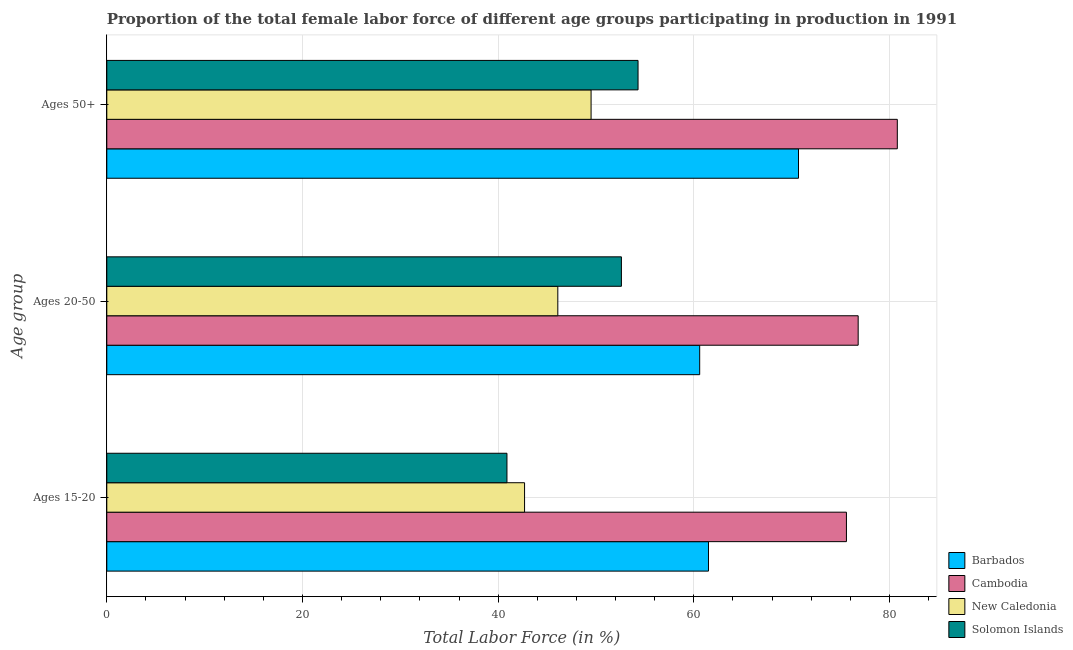How many different coloured bars are there?
Make the answer very short. 4. Are the number of bars per tick equal to the number of legend labels?
Offer a terse response. Yes. Are the number of bars on each tick of the Y-axis equal?
Give a very brief answer. Yes. What is the label of the 3rd group of bars from the top?
Offer a terse response. Ages 15-20. What is the percentage of female labor force within the age group 20-50 in Solomon Islands?
Ensure brevity in your answer.  52.6. Across all countries, what is the maximum percentage of female labor force within the age group 20-50?
Ensure brevity in your answer.  76.8. Across all countries, what is the minimum percentage of female labor force within the age group 20-50?
Offer a very short reply. 46.1. In which country was the percentage of female labor force above age 50 maximum?
Give a very brief answer. Cambodia. In which country was the percentage of female labor force above age 50 minimum?
Keep it short and to the point. New Caledonia. What is the total percentage of female labor force within the age group 20-50 in the graph?
Provide a succinct answer. 236.1. What is the difference between the percentage of female labor force within the age group 20-50 in Cambodia and that in New Caledonia?
Make the answer very short. 30.7. What is the difference between the percentage of female labor force within the age group 20-50 in New Caledonia and the percentage of female labor force above age 50 in Cambodia?
Ensure brevity in your answer.  -34.7. What is the average percentage of female labor force above age 50 per country?
Offer a very short reply. 63.82. What is the difference between the percentage of female labor force within the age group 20-50 and percentage of female labor force above age 50 in New Caledonia?
Give a very brief answer. -3.4. What is the ratio of the percentage of female labor force within the age group 20-50 in New Caledonia to that in Barbados?
Offer a very short reply. 0.76. What is the difference between the highest and the second highest percentage of female labor force within the age group 15-20?
Make the answer very short. 14.1. What is the difference between the highest and the lowest percentage of female labor force within the age group 15-20?
Your answer should be compact. 34.7. In how many countries, is the percentage of female labor force above age 50 greater than the average percentage of female labor force above age 50 taken over all countries?
Make the answer very short. 2. Is the sum of the percentage of female labor force within the age group 20-50 in New Caledonia and Barbados greater than the maximum percentage of female labor force above age 50 across all countries?
Your response must be concise. Yes. What does the 4th bar from the top in Ages 15-20 represents?
Your answer should be compact. Barbados. What does the 2nd bar from the bottom in Ages 20-50 represents?
Your answer should be very brief. Cambodia. Is it the case that in every country, the sum of the percentage of female labor force within the age group 15-20 and percentage of female labor force within the age group 20-50 is greater than the percentage of female labor force above age 50?
Your answer should be compact. Yes. What is the difference between two consecutive major ticks on the X-axis?
Your answer should be very brief. 20. Does the graph contain any zero values?
Provide a short and direct response. No. Does the graph contain grids?
Your answer should be very brief. Yes. What is the title of the graph?
Make the answer very short. Proportion of the total female labor force of different age groups participating in production in 1991. What is the label or title of the X-axis?
Your response must be concise. Total Labor Force (in %). What is the label or title of the Y-axis?
Make the answer very short. Age group. What is the Total Labor Force (in %) in Barbados in Ages 15-20?
Offer a terse response. 61.5. What is the Total Labor Force (in %) in Cambodia in Ages 15-20?
Provide a succinct answer. 75.6. What is the Total Labor Force (in %) of New Caledonia in Ages 15-20?
Your answer should be compact. 42.7. What is the Total Labor Force (in %) of Solomon Islands in Ages 15-20?
Make the answer very short. 40.9. What is the Total Labor Force (in %) of Barbados in Ages 20-50?
Your response must be concise. 60.6. What is the Total Labor Force (in %) of Cambodia in Ages 20-50?
Provide a succinct answer. 76.8. What is the Total Labor Force (in %) in New Caledonia in Ages 20-50?
Your answer should be very brief. 46.1. What is the Total Labor Force (in %) of Solomon Islands in Ages 20-50?
Your response must be concise. 52.6. What is the Total Labor Force (in %) in Barbados in Ages 50+?
Your answer should be compact. 70.7. What is the Total Labor Force (in %) of Cambodia in Ages 50+?
Give a very brief answer. 80.8. What is the Total Labor Force (in %) of New Caledonia in Ages 50+?
Your answer should be very brief. 49.5. What is the Total Labor Force (in %) of Solomon Islands in Ages 50+?
Your response must be concise. 54.3. Across all Age group, what is the maximum Total Labor Force (in %) in Barbados?
Make the answer very short. 70.7. Across all Age group, what is the maximum Total Labor Force (in %) of Cambodia?
Ensure brevity in your answer.  80.8. Across all Age group, what is the maximum Total Labor Force (in %) of New Caledonia?
Your answer should be compact. 49.5. Across all Age group, what is the maximum Total Labor Force (in %) of Solomon Islands?
Provide a short and direct response. 54.3. Across all Age group, what is the minimum Total Labor Force (in %) in Barbados?
Offer a terse response. 60.6. Across all Age group, what is the minimum Total Labor Force (in %) in Cambodia?
Ensure brevity in your answer.  75.6. Across all Age group, what is the minimum Total Labor Force (in %) in New Caledonia?
Give a very brief answer. 42.7. Across all Age group, what is the minimum Total Labor Force (in %) of Solomon Islands?
Ensure brevity in your answer.  40.9. What is the total Total Labor Force (in %) of Barbados in the graph?
Your response must be concise. 192.8. What is the total Total Labor Force (in %) in Cambodia in the graph?
Provide a succinct answer. 233.2. What is the total Total Labor Force (in %) of New Caledonia in the graph?
Your answer should be very brief. 138.3. What is the total Total Labor Force (in %) of Solomon Islands in the graph?
Give a very brief answer. 147.8. What is the difference between the Total Labor Force (in %) of New Caledonia in Ages 15-20 and that in Ages 20-50?
Provide a short and direct response. -3.4. What is the difference between the Total Labor Force (in %) in Solomon Islands in Ages 15-20 and that in Ages 50+?
Provide a short and direct response. -13.4. What is the difference between the Total Labor Force (in %) of Barbados in Ages 15-20 and the Total Labor Force (in %) of Cambodia in Ages 20-50?
Give a very brief answer. -15.3. What is the difference between the Total Labor Force (in %) in Barbados in Ages 15-20 and the Total Labor Force (in %) in Solomon Islands in Ages 20-50?
Give a very brief answer. 8.9. What is the difference between the Total Labor Force (in %) of Cambodia in Ages 15-20 and the Total Labor Force (in %) of New Caledonia in Ages 20-50?
Provide a short and direct response. 29.5. What is the difference between the Total Labor Force (in %) of Barbados in Ages 15-20 and the Total Labor Force (in %) of Cambodia in Ages 50+?
Provide a short and direct response. -19.3. What is the difference between the Total Labor Force (in %) in Barbados in Ages 15-20 and the Total Labor Force (in %) in New Caledonia in Ages 50+?
Ensure brevity in your answer.  12. What is the difference between the Total Labor Force (in %) of Barbados in Ages 15-20 and the Total Labor Force (in %) of Solomon Islands in Ages 50+?
Your response must be concise. 7.2. What is the difference between the Total Labor Force (in %) of Cambodia in Ages 15-20 and the Total Labor Force (in %) of New Caledonia in Ages 50+?
Your response must be concise. 26.1. What is the difference between the Total Labor Force (in %) of Cambodia in Ages 15-20 and the Total Labor Force (in %) of Solomon Islands in Ages 50+?
Provide a short and direct response. 21.3. What is the difference between the Total Labor Force (in %) of New Caledonia in Ages 15-20 and the Total Labor Force (in %) of Solomon Islands in Ages 50+?
Offer a terse response. -11.6. What is the difference between the Total Labor Force (in %) in Barbados in Ages 20-50 and the Total Labor Force (in %) in Cambodia in Ages 50+?
Offer a terse response. -20.2. What is the difference between the Total Labor Force (in %) of Barbados in Ages 20-50 and the Total Labor Force (in %) of Solomon Islands in Ages 50+?
Keep it short and to the point. 6.3. What is the difference between the Total Labor Force (in %) in Cambodia in Ages 20-50 and the Total Labor Force (in %) in New Caledonia in Ages 50+?
Ensure brevity in your answer.  27.3. What is the difference between the Total Labor Force (in %) in New Caledonia in Ages 20-50 and the Total Labor Force (in %) in Solomon Islands in Ages 50+?
Make the answer very short. -8.2. What is the average Total Labor Force (in %) in Barbados per Age group?
Keep it short and to the point. 64.27. What is the average Total Labor Force (in %) in Cambodia per Age group?
Offer a terse response. 77.73. What is the average Total Labor Force (in %) in New Caledonia per Age group?
Offer a terse response. 46.1. What is the average Total Labor Force (in %) of Solomon Islands per Age group?
Your response must be concise. 49.27. What is the difference between the Total Labor Force (in %) of Barbados and Total Labor Force (in %) of Cambodia in Ages 15-20?
Provide a succinct answer. -14.1. What is the difference between the Total Labor Force (in %) of Barbados and Total Labor Force (in %) of Solomon Islands in Ages 15-20?
Your answer should be very brief. 20.6. What is the difference between the Total Labor Force (in %) in Cambodia and Total Labor Force (in %) in New Caledonia in Ages 15-20?
Provide a succinct answer. 32.9. What is the difference between the Total Labor Force (in %) in Cambodia and Total Labor Force (in %) in Solomon Islands in Ages 15-20?
Your answer should be very brief. 34.7. What is the difference between the Total Labor Force (in %) of Barbados and Total Labor Force (in %) of Cambodia in Ages 20-50?
Your answer should be compact. -16.2. What is the difference between the Total Labor Force (in %) of Barbados and Total Labor Force (in %) of New Caledonia in Ages 20-50?
Offer a terse response. 14.5. What is the difference between the Total Labor Force (in %) in Cambodia and Total Labor Force (in %) in New Caledonia in Ages 20-50?
Your response must be concise. 30.7. What is the difference between the Total Labor Force (in %) in Cambodia and Total Labor Force (in %) in Solomon Islands in Ages 20-50?
Keep it short and to the point. 24.2. What is the difference between the Total Labor Force (in %) of New Caledonia and Total Labor Force (in %) of Solomon Islands in Ages 20-50?
Give a very brief answer. -6.5. What is the difference between the Total Labor Force (in %) of Barbados and Total Labor Force (in %) of New Caledonia in Ages 50+?
Provide a succinct answer. 21.2. What is the difference between the Total Labor Force (in %) of Barbados and Total Labor Force (in %) of Solomon Islands in Ages 50+?
Give a very brief answer. 16.4. What is the difference between the Total Labor Force (in %) of Cambodia and Total Labor Force (in %) of New Caledonia in Ages 50+?
Offer a terse response. 31.3. What is the difference between the Total Labor Force (in %) of New Caledonia and Total Labor Force (in %) of Solomon Islands in Ages 50+?
Provide a short and direct response. -4.8. What is the ratio of the Total Labor Force (in %) of Barbados in Ages 15-20 to that in Ages 20-50?
Provide a succinct answer. 1.01. What is the ratio of the Total Labor Force (in %) of Cambodia in Ages 15-20 to that in Ages 20-50?
Offer a terse response. 0.98. What is the ratio of the Total Labor Force (in %) in New Caledonia in Ages 15-20 to that in Ages 20-50?
Provide a succinct answer. 0.93. What is the ratio of the Total Labor Force (in %) in Solomon Islands in Ages 15-20 to that in Ages 20-50?
Offer a very short reply. 0.78. What is the ratio of the Total Labor Force (in %) of Barbados in Ages 15-20 to that in Ages 50+?
Ensure brevity in your answer.  0.87. What is the ratio of the Total Labor Force (in %) in Cambodia in Ages 15-20 to that in Ages 50+?
Make the answer very short. 0.94. What is the ratio of the Total Labor Force (in %) in New Caledonia in Ages 15-20 to that in Ages 50+?
Provide a short and direct response. 0.86. What is the ratio of the Total Labor Force (in %) of Solomon Islands in Ages 15-20 to that in Ages 50+?
Your response must be concise. 0.75. What is the ratio of the Total Labor Force (in %) of Barbados in Ages 20-50 to that in Ages 50+?
Keep it short and to the point. 0.86. What is the ratio of the Total Labor Force (in %) in Cambodia in Ages 20-50 to that in Ages 50+?
Provide a succinct answer. 0.95. What is the ratio of the Total Labor Force (in %) of New Caledonia in Ages 20-50 to that in Ages 50+?
Ensure brevity in your answer.  0.93. What is the ratio of the Total Labor Force (in %) in Solomon Islands in Ages 20-50 to that in Ages 50+?
Make the answer very short. 0.97. What is the difference between the highest and the second highest Total Labor Force (in %) of Barbados?
Keep it short and to the point. 9.2. What is the difference between the highest and the lowest Total Labor Force (in %) of Barbados?
Offer a very short reply. 10.1. What is the difference between the highest and the lowest Total Labor Force (in %) of Cambodia?
Provide a short and direct response. 5.2. What is the difference between the highest and the lowest Total Labor Force (in %) in Solomon Islands?
Make the answer very short. 13.4. 